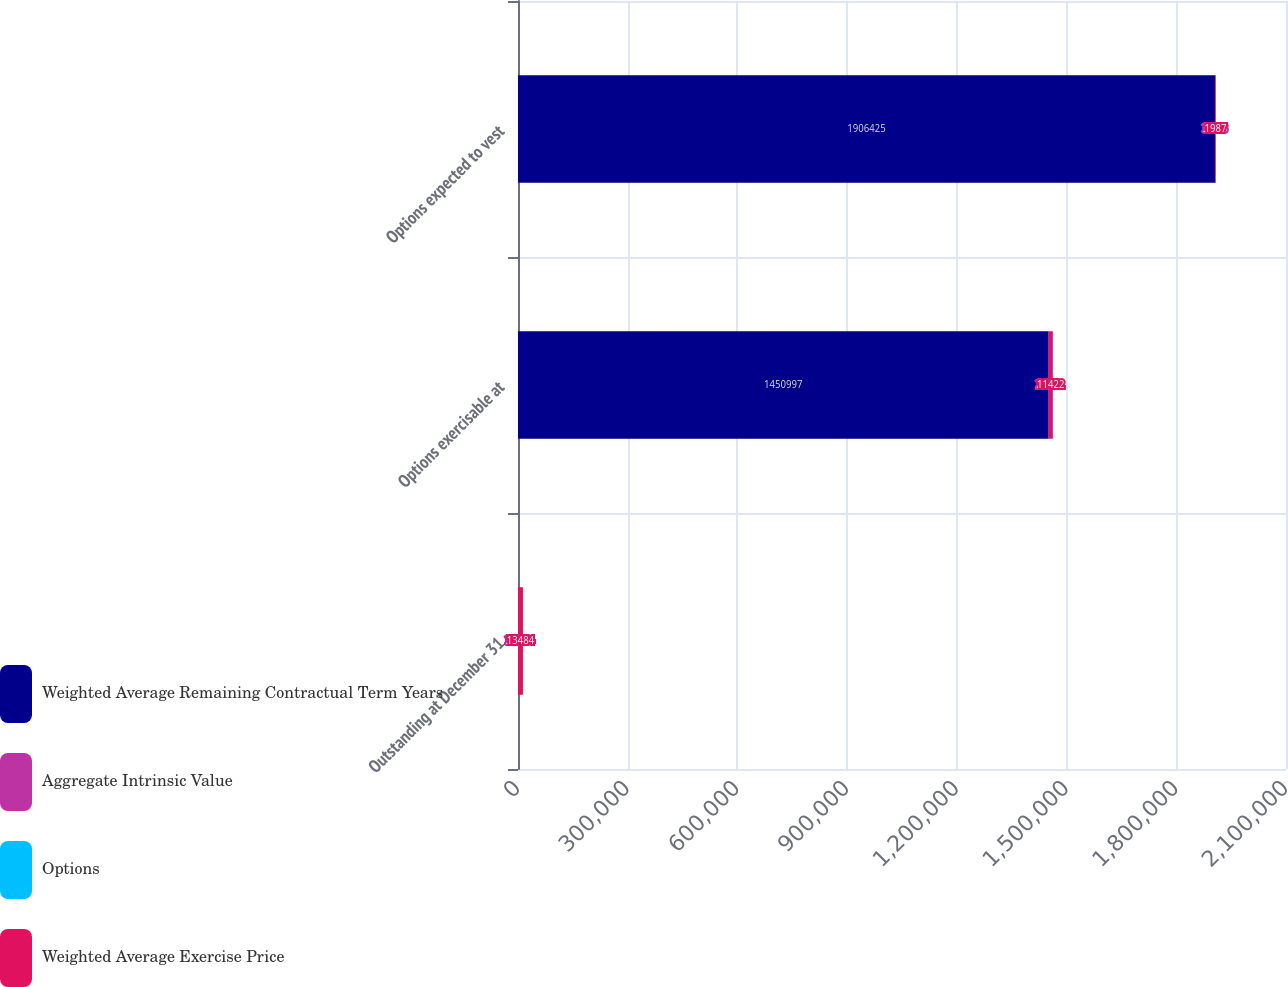<chart> <loc_0><loc_0><loc_500><loc_500><stacked_bar_chart><ecel><fcel>Outstanding at December 31<fcel>Options exercisable at<fcel>Options expected to vest<nl><fcel>Weighted Average Remaining Contractual Term Years<fcel>35.73<fcel>1.451e+06<fcel>1.90642e+06<nl><fcel>Aggregate Intrinsic Value<fcel>31.79<fcel>26.38<fcel>35.73<nl><fcel>Options<fcel>6.9<fcel>4.42<fcel>8.68<nl><fcel>Weighted Average Exercise Price<fcel>13484<fcel>11422<fcel>1987<nl></chart> 